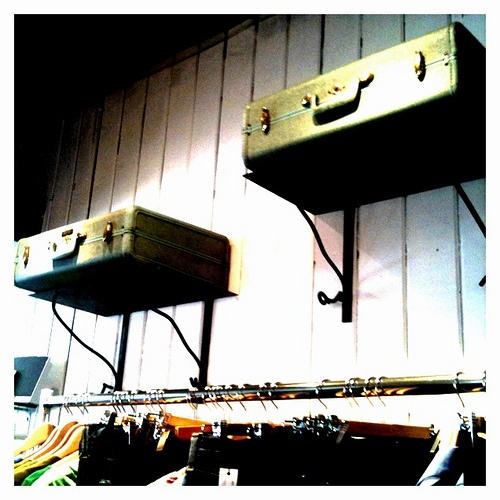Describe the objects in this image and their specific colors. I can see suitcase in white, black, ivory, khaki, and tan tones and suitcase in white, black, ivory, khaki, and tan tones in this image. 